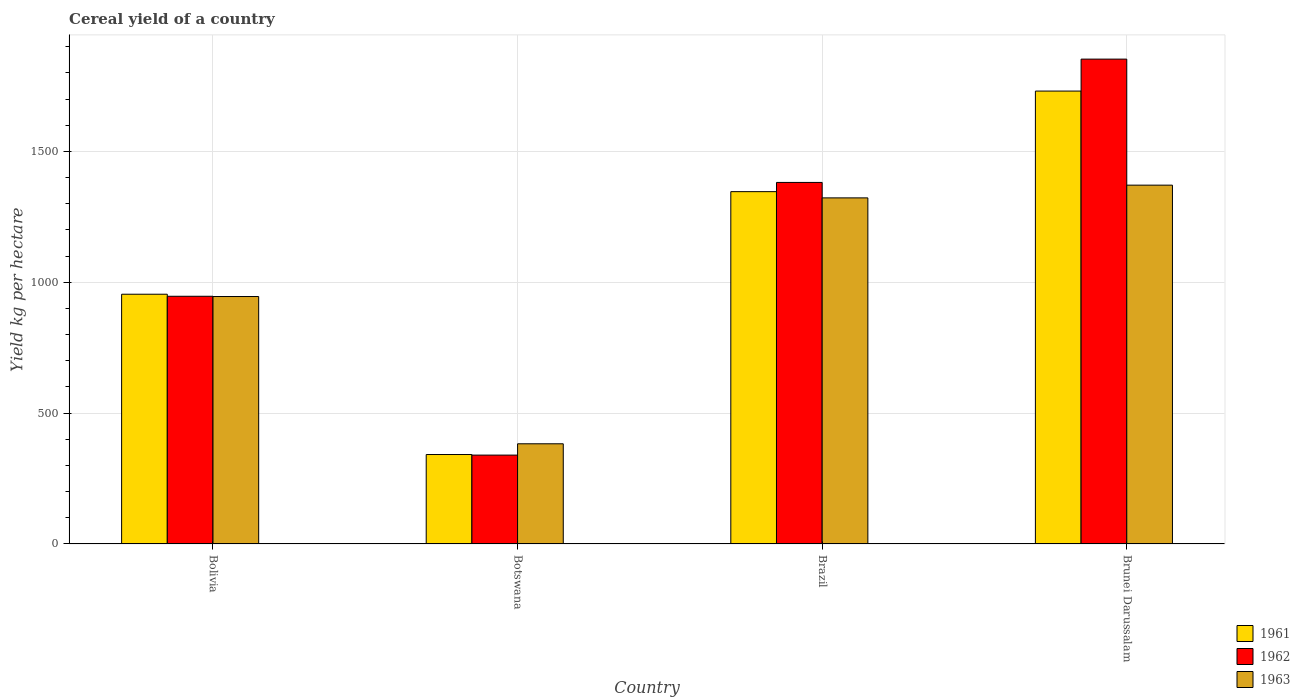How many groups of bars are there?
Give a very brief answer. 4. Are the number of bars per tick equal to the number of legend labels?
Offer a terse response. Yes. How many bars are there on the 3rd tick from the left?
Offer a terse response. 3. How many bars are there on the 2nd tick from the right?
Your answer should be very brief. 3. What is the total cereal yield in 1963 in Brazil?
Keep it short and to the point. 1322.44. Across all countries, what is the maximum total cereal yield in 1961?
Give a very brief answer. 1730.61. Across all countries, what is the minimum total cereal yield in 1963?
Ensure brevity in your answer.  382.79. In which country was the total cereal yield in 1963 maximum?
Ensure brevity in your answer.  Brunei Darussalam. In which country was the total cereal yield in 1962 minimum?
Make the answer very short. Botswana. What is the total total cereal yield in 1963 in the graph?
Your answer should be compact. 4021.92. What is the difference between the total cereal yield in 1963 in Botswana and that in Brunei Darussalam?
Ensure brevity in your answer.  -988.36. What is the difference between the total cereal yield in 1962 in Bolivia and the total cereal yield in 1963 in Brunei Darussalam?
Keep it short and to the point. -424.63. What is the average total cereal yield in 1961 per country?
Give a very brief answer. 1093.26. What is the difference between the total cereal yield of/in 1963 and total cereal yield of/in 1962 in Brunei Darussalam?
Give a very brief answer. -481.56. In how many countries, is the total cereal yield in 1962 greater than 400 kg per hectare?
Give a very brief answer. 3. What is the ratio of the total cereal yield in 1961 in Botswana to that in Brunei Darussalam?
Your answer should be very brief. 0.2. What is the difference between the highest and the second highest total cereal yield in 1963?
Your answer should be compact. -376.9. What is the difference between the highest and the lowest total cereal yield in 1963?
Give a very brief answer. 988.36. What does the 1st bar from the right in Brazil represents?
Give a very brief answer. 1963. Is it the case that in every country, the sum of the total cereal yield in 1963 and total cereal yield in 1962 is greater than the total cereal yield in 1961?
Your answer should be very brief. Yes. Are all the bars in the graph horizontal?
Offer a very short reply. No. What is the difference between two consecutive major ticks on the Y-axis?
Offer a very short reply. 500. Does the graph contain grids?
Provide a short and direct response. Yes. Where does the legend appear in the graph?
Make the answer very short. Bottom right. What is the title of the graph?
Provide a short and direct response. Cereal yield of a country. Does "1976" appear as one of the legend labels in the graph?
Provide a succinct answer. No. What is the label or title of the X-axis?
Your response must be concise. Country. What is the label or title of the Y-axis?
Provide a succinct answer. Yield kg per hectare. What is the Yield kg per hectare in 1961 in Bolivia?
Ensure brevity in your answer.  954.34. What is the Yield kg per hectare in 1962 in Bolivia?
Ensure brevity in your answer.  946.51. What is the Yield kg per hectare of 1963 in Bolivia?
Your response must be concise. 945.54. What is the Yield kg per hectare of 1961 in Botswana?
Keep it short and to the point. 341.81. What is the Yield kg per hectare of 1962 in Botswana?
Your response must be concise. 339.58. What is the Yield kg per hectare of 1963 in Botswana?
Your answer should be very brief. 382.79. What is the Yield kg per hectare of 1961 in Brazil?
Your answer should be very brief. 1346.3. What is the Yield kg per hectare in 1962 in Brazil?
Your answer should be very brief. 1381.52. What is the Yield kg per hectare in 1963 in Brazil?
Your answer should be very brief. 1322.44. What is the Yield kg per hectare of 1961 in Brunei Darussalam?
Provide a succinct answer. 1730.61. What is the Yield kg per hectare in 1962 in Brunei Darussalam?
Keep it short and to the point. 1852.7. What is the Yield kg per hectare in 1963 in Brunei Darussalam?
Your answer should be very brief. 1371.14. Across all countries, what is the maximum Yield kg per hectare of 1961?
Your response must be concise. 1730.61. Across all countries, what is the maximum Yield kg per hectare of 1962?
Ensure brevity in your answer.  1852.7. Across all countries, what is the maximum Yield kg per hectare of 1963?
Your answer should be compact. 1371.14. Across all countries, what is the minimum Yield kg per hectare in 1961?
Your answer should be compact. 341.81. Across all countries, what is the minimum Yield kg per hectare in 1962?
Offer a very short reply. 339.58. Across all countries, what is the minimum Yield kg per hectare in 1963?
Your answer should be very brief. 382.79. What is the total Yield kg per hectare of 1961 in the graph?
Provide a short and direct response. 4373.05. What is the total Yield kg per hectare in 1962 in the graph?
Provide a short and direct response. 4520.31. What is the total Yield kg per hectare of 1963 in the graph?
Offer a terse response. 4021.92. What is the difference between the Yield kg per hectare of 1961 in Bolivia and that in Botswana?
Give a very brief answer. 612.53. What is the difference between the Yield kg per hectare in 1962 in Bolivia and that in Botswana?
Your answer should be very brief. 606.94. What is the difference between the Yield kg per hectare of 1963 in Bolivia and that in Botswana?
Your answer should be very brief. 562.75. What is the difference between the Yield kg per hectare in 1961 in Bolivia and that in Brazil?
Your answer should be compact. -391.97. What is the difference between the Yield kg per hectare of 1962 in Bolivia and that in Brazil?
Your answer should be compact. -435.01. What is the difference between the Yield kg per hectare of 1963 in Bolivia and that in Brazil?
Provide a short and direct response. -376.9. What is the difference between the Yield kg per hectare in 1961 in Bolivia and that in Brunei Darussalam?
Make the answer very short. -776.27. What is the difference between the Yield kg per hectare of 1962 in Bolivia and that in Brunei Darussalam?
Your answer should be very brief. -906.19. What is the difference between the Yield kg per hectare of 1963 in Bolivia and that in Brunei Darussalam?
Ensure brevity in your answer.  -425.61. What is the difference between the Yield kg per hectare of 1961 in Botswana and that in Brazil?
Your response must be concise. -1004.49. What is the difference between the Yield kg per hectare in 1962 in Botswana and that in Brazil?
Keep it short and to the point. -1041.95. What is the difference between the Yield kg per hectare of 1963 in Botswana and that in Brazil?
Provide a short and direct response. -939.65. What is the difference between the Yield kg per hectare in 1961 in Botswana and that in Brunei Darussalam?
Provide a succinct answer. -1388.8. What is the difference between the Yield kg per hectare in 1962 in Botswana and that in Brunei Darussalam?
Offer a very short reply. -1513.13. What is the difference between the Yield kg per hectare in 1963 in Botswana and that in Brunei Darussalam?
Make the answer very short. -988.36. What is the difference between the Yield kg per hectare in 1961 in Brazil and that in Brunei Darussalam?
Your answer should be compact. -384.31. What is the difference between the Yield kg per hectare of 1962 in Brazil and that in Brunei Darussalam?
Your answer should be compact. -471.18. What is the difference between the Yield kg per hectare of 1963 in Brazil and that in Brunei Darussalam?
Ensure brevity in your answer.  -48.7. What is the difference between the Yield kg per hectare in 1961 in Bolivia and the Yield kg per hectare in 1962 in Botswana?
Your answer should be very brief. 614.76. What is the difference between the Yield kg per hectare of 1961 in Bolivia and the Yield kg per hectare of 1963 in Botswana?
Offer a very short reply. 571.54. What is the difference between the Yield kg per hectare in 1962 in Bolivia and the Yield kg per hectare in 1963 in Botswana?
Keep it short and to the point. 563.72. What is the difference between the Yield kg per hectare in 1961 in Bolivia and the Yield kg per hectare in 1962 in Brazil?
Your answer should be very brief. -427.19. What is the difference between the Yield kg per hectare of 1961 in Bolivia and the Yield kg per hectare of 1963 in Brazil?
Ensure brevity in your answer.  -368.11. What is the difference between the Yield kg per hectare in 1962 in Bolivia and the Yield kg per hectare in 1963 in Brazil?
Make the answer very short. -375.93. What is the difference between the Yield kg per hectare of 1961 in Bolivia and the Yield kg per hectare of 1962 in Brunei Darussalam?
Offer a very short reply. -898.37. What is the difference between the Yield kg per hectare of 1961 in Bolivia and the Yield kg per hectare of 1963 in Brunei Darussalam?
Provide a short and direct response. -416.81. What is the difference between the Yield kg per hectare in 1962 in Bolivia and the Yield kg per hectare in 1963 in Brunei Darussalam?
Offer a terse response. -424.63. What is the difference between the Yield kg per hectare in 1961 in Botswana and the Yield kg per hectare in 1962 in Brazil?
Your answer should be very brief. -1039.71. What is the difference between the Yield kg per hectare of 1961 in Botswana and the Yield kg per hectare of 1963 in Brazil?
Your response must be concise. -980.64. What is the difference between the Yield kg per hectare of 1962 in Botswana and the Yield kg per hectare of 1963 in Brazil?
Give a very brief answer. -982.87. What is the difference between the Yield kg per hectare in 1961 in Botswana and the Yield kg per hectare in 1962 in Brunei Darussalam?
Offer a terse response. -1510.89. What is the difference between the Yield kg per hectare in 1961 in Botswana and the Yield kg per hectare in 1963 in Brunei Darussalam?
Keep it short and to the point. -1029.34. What is the difference between the Yield kg per hectare in 1962 in Botswana and the Yield kg per hectare in 1963 in Brunei Darussalam?
Your answer should be very brief. -1031.57. What is the difference between the Yield kg per hectare in 1961 in Brazil and the Yield kg per hectare in 1962 in Brunei Darussalam?
Give a very brief answer. -506.4. What is the difference between the Yield kg per hectare in 1961 in Brazil and the Yield kg per hectare in 1963 in Brunei Darussalam?
Make the answer very short. -24.84. What is the difference between the Yield kg per hectare of 1962 in Brazil and the Yield kg per hectare of 1963 in Brunei Darussalam?
Provide a short and direct response. 10.38. What is the average Yield kg per hectare of 1961 per country?
Ensure brevity in your answer.  1093.26. What is the average Yield kg per hectare of 1962 per country?
Provide a short and direct response. 1130.08. What is the average Yield kg per hectare of 1963 per country?
Your answer should be very brief. 1005.48. What is the difference between the Yield kg per hectare in 1961 and Yield kg per hectare in 1962 in Bolivia?
Keep it short and to the point. 7.82. What is the difference between the Yield kg per hectare in 1961 and Yield kg per hectare in 1963 in Bolivia?
Keep it short and to the point. 8.79. What is the difference between the Yield kg per hectare in 1962 and Yield kg per hectare in 1963 in Bolivia?
Your response must be concise. 0.97. What is the difference between the Yield kg per hectare in 1961 and Yield kg per hectare in 1962 in Botswana?
Offer a terse response. 2.23. What is the difference between the Yield kg per hectare of 1961 and Yield kg per hectare of 1963 in Botswana?
Offer a very short reply. -40.98. What is the difference between the Yield kg per hectare in 1962 and Yield kg per hectare in 1963 in Botswana?
Ensure brevity in your answer.  -43.21. What is the difference between the Yield kg per hectare of 1961 and Yield kg per hectare of 1962 in Brazil?
Provide a short and direct response. -35.22. What is the difference between the Yield kg per hectare of 1961 and Yield kg per hectare of 1963 in Brazil?
Provide a succinct answer. 23.86. What is the difference between the Yield kg per hectare of 1962 and Yield kg per hectare of 1963 in Brazil?
Make the answer very short. 59.08. What is the difference between the Yield kg per hectare of 1961 and Yield kg per hectare of 1962 in Brunei Darussalam?
Provide a short and direct response. -122.1. What is the difference between the Yield kg per hectare in 1961 and Yield kg per hectare in 1963 in Brunei Darussalam?
Provide a succinct answer. 359.46. What is the difference between the Yield kg per hectare of 1962 and Yield kg per hectare of 1963 in Brunei Darussalam?
Give a very brief answer. 481.56. What is the ratio of the Yield kg per hectare of 1961 in Bolivia to that in Botswana?
Provide a short and direct response. 2.79. What is the ratio of the Yield kg per hectare of 1962 in Bolivia to that in Botswana?
Your answer should be compact. 2.79. What is the ratio of the Yield kg per hectare in 1963 in Bolivia to that in Botswana?
Provide a short and direct response. 2.47. What is the ratio of the Yield kg per hectare in 1961 in Bolivia to that in Brazil?
Ensure brevity in your answer.  0.71. What is the ratio of the Yield kg per hectare of 1962 in Bolivia to that in Brazil?
Your response must be concise. 0.69. What is the ratio of the Yield kg per hectare of 1963 in Bolivia to that in Brazil?
Ensure brevity in your answer.  0.71. What is the ratio of the Yield kg per hectare of 1961 in Bolivia to that in Brunei Darussalam?
Ensure brevity in your answer.  0.55. What is the ratio of the Yield kg per hectare in 1962 in Bolivia to that in Brunei Darussalam?
Your response must be concise. 0.51. What is the ratio of the Yield kg per hectare of 1963 in Bolivia to that in Brunei Darussalam?
Your answer should be very brief. 0.69. What is the ratio of the Yield kg per hectare in 1961 in Botswana to that in Brazil?
Provide a short and direct response. 0.25. What is the ratio of the Yield kg per hectare in 1962 in Botswana to that in Brazil?
Make the answer very short. 0.25. What is the ratio of the Yield kg per hectare in 1963 in Botswana to that in Brazil?
Your answer should be compact. 0.29. What is the ratio of the Yield kg per hectare of 1961 in Botswana to that in Brunei Darussalam?
Provide a short and direct response. 0.2. What is the ratio of the Yield kg per hectare in 1962 in Botswana to that in Brunei Darussalam?
Offer a very short reply. 0.18. What is the ratio of the Yield kg per hectare of 1963 in Botswana to that in Brunei Darussalam?
Your answer should be very brief. 0.28. What is the ratio of the Yield kg per hectare in 1961 in Brazil to that in Brunei Darussalam?
Provide a short and direct response. 0.78. What is the ratio of the Yield kg per hectare in 1962 in Brazil to that in Brunei Darussalam?
Offer a terse response. 0.75. What is the ratio of the Yield kg per hectare in 1963 in Brazil to that in Brunei Darussalam?
Give a very brief answer. 0.96. What is the difference between the highest and the second highest Yield kg per hectare in 1961?
Keep it short and to the point. 384.31. What is the difference between the highest and the second highest Yield kg per hectare of 1962?
Provide a succinct answer. 471.18. What is the difference between the highest and the second highest Yield kg per hectare in 1963?
Your answer should be compact. 48.7. What is the difference between the highest and the lowest Yield kg per hectare of 1961?
Your response must be concise. 1388.8. What is the difference between the highest and the lowest Yield kg per hectare in 1962?
Offer a very short reply. 1513.13. What is the difference between the highest and the lowest Yield kg per hectare of 1963?
Offer a terse response. 988.36. 